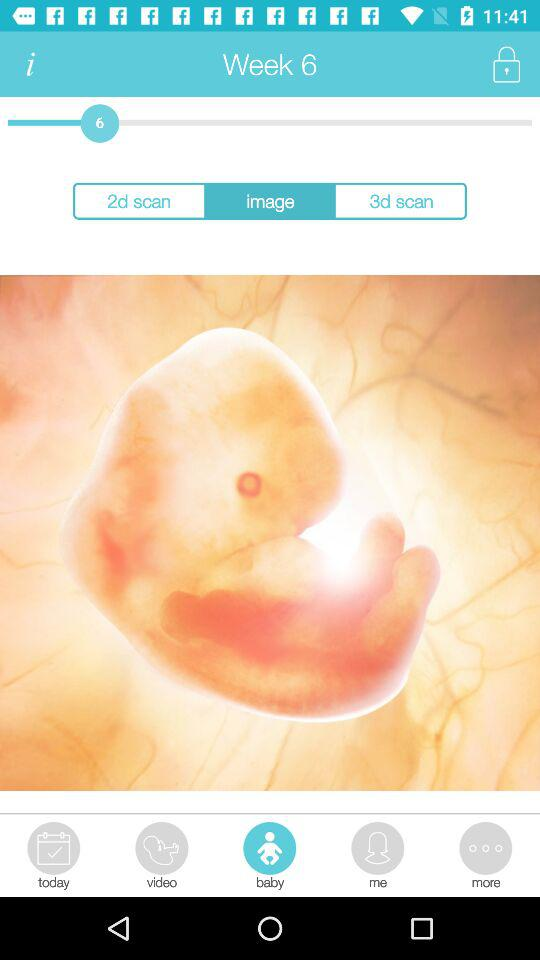How many weeks pregnant is the woman?
Answer the question using a single word or phrase. 6 